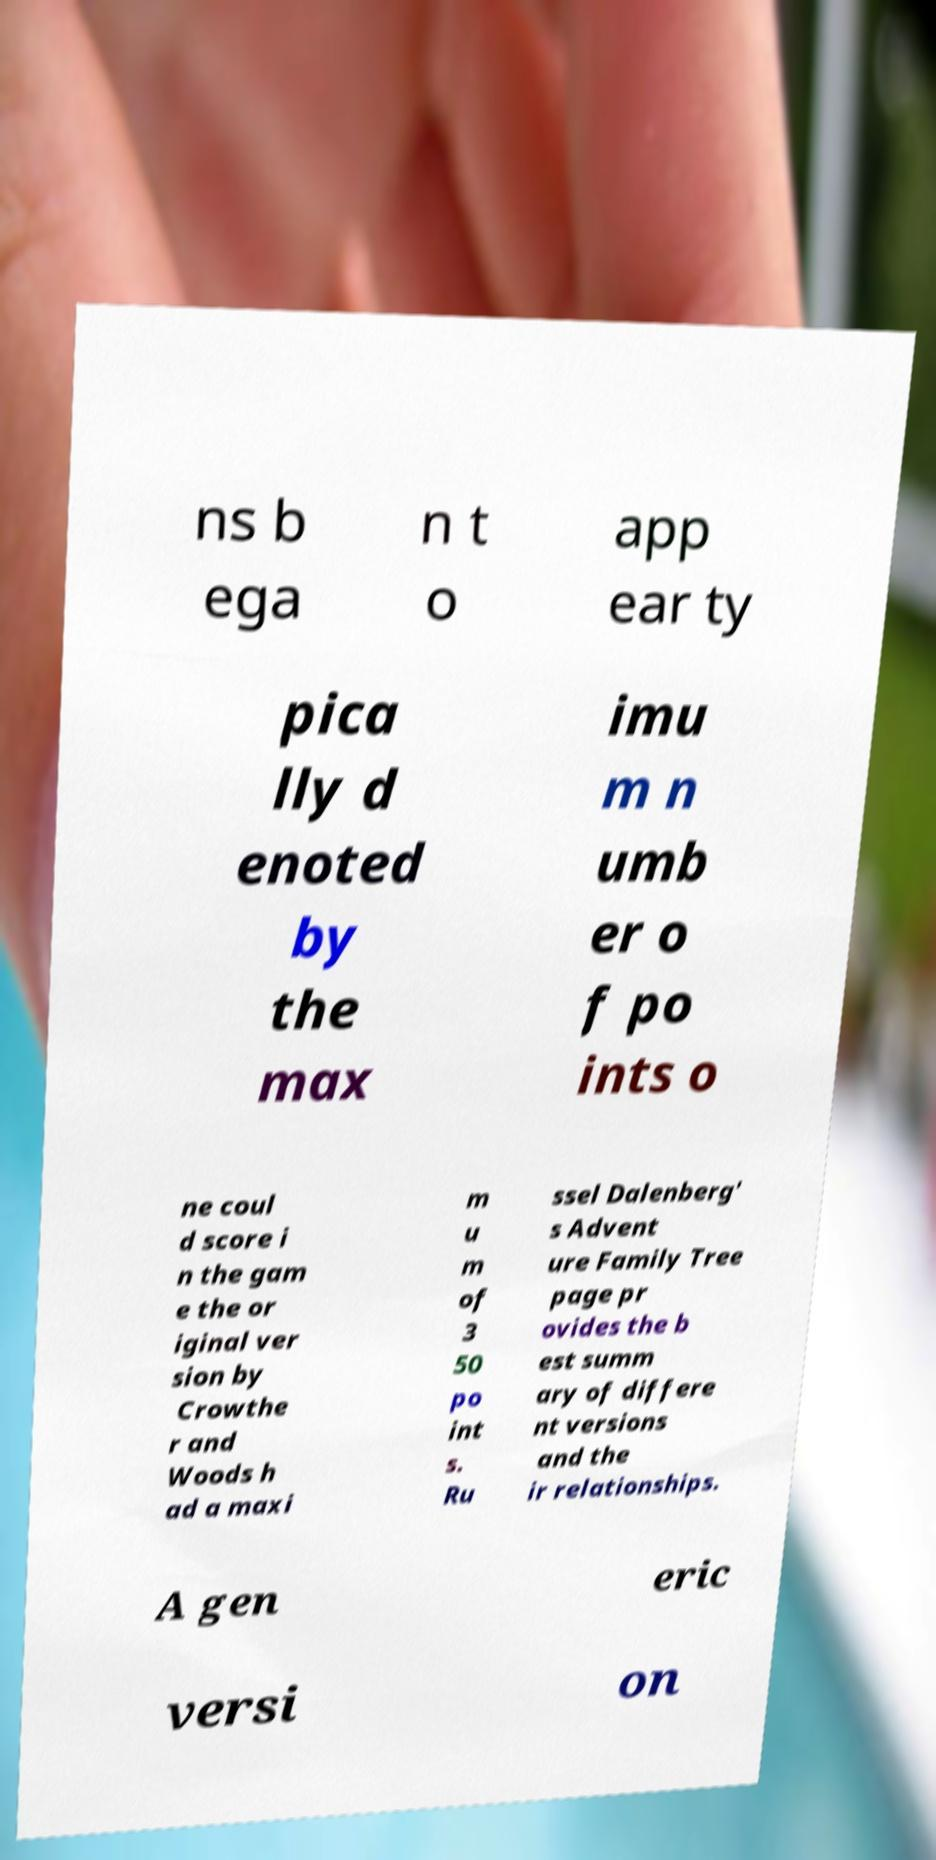For documentation purposes, I need the text within this image transcribed. Could you provide that? ns b ega n t o app ear ty pica lly d enoted by the max imu m n umb er o f po ints o ne coul d score i n the gam e the or iginal ver sion by Crowthe r and Woods h ad a maxi m u m of 3 50 po int s. Ru ssel Dalenberg' s Advent ure Family Tree page pr ovides the b est summ ary of differe nt versions and the ir relationships. A gen eric versi on 